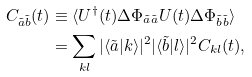Convert formula to latex. <formula><loc_0><loc_0><loc_500><loc_500>C _ { \tilde { a } \tilde { b } } ( t ) & \equiv \langle U ^ { \dagger } ( t ) \Delta \Phi _ { \tilde { a } \tilde { a } } U ( t ) \Delta \Phi _ { \tilde { b } \tilde { b } } \rangle \\ & = \sum _ { k l } | \langle \tilde { a } | k \rangle | ^ { 2 } | \langle \tilde { b } | l \rangle | ^ { 2 } C _ { k l } ( t ) ,</formula> 